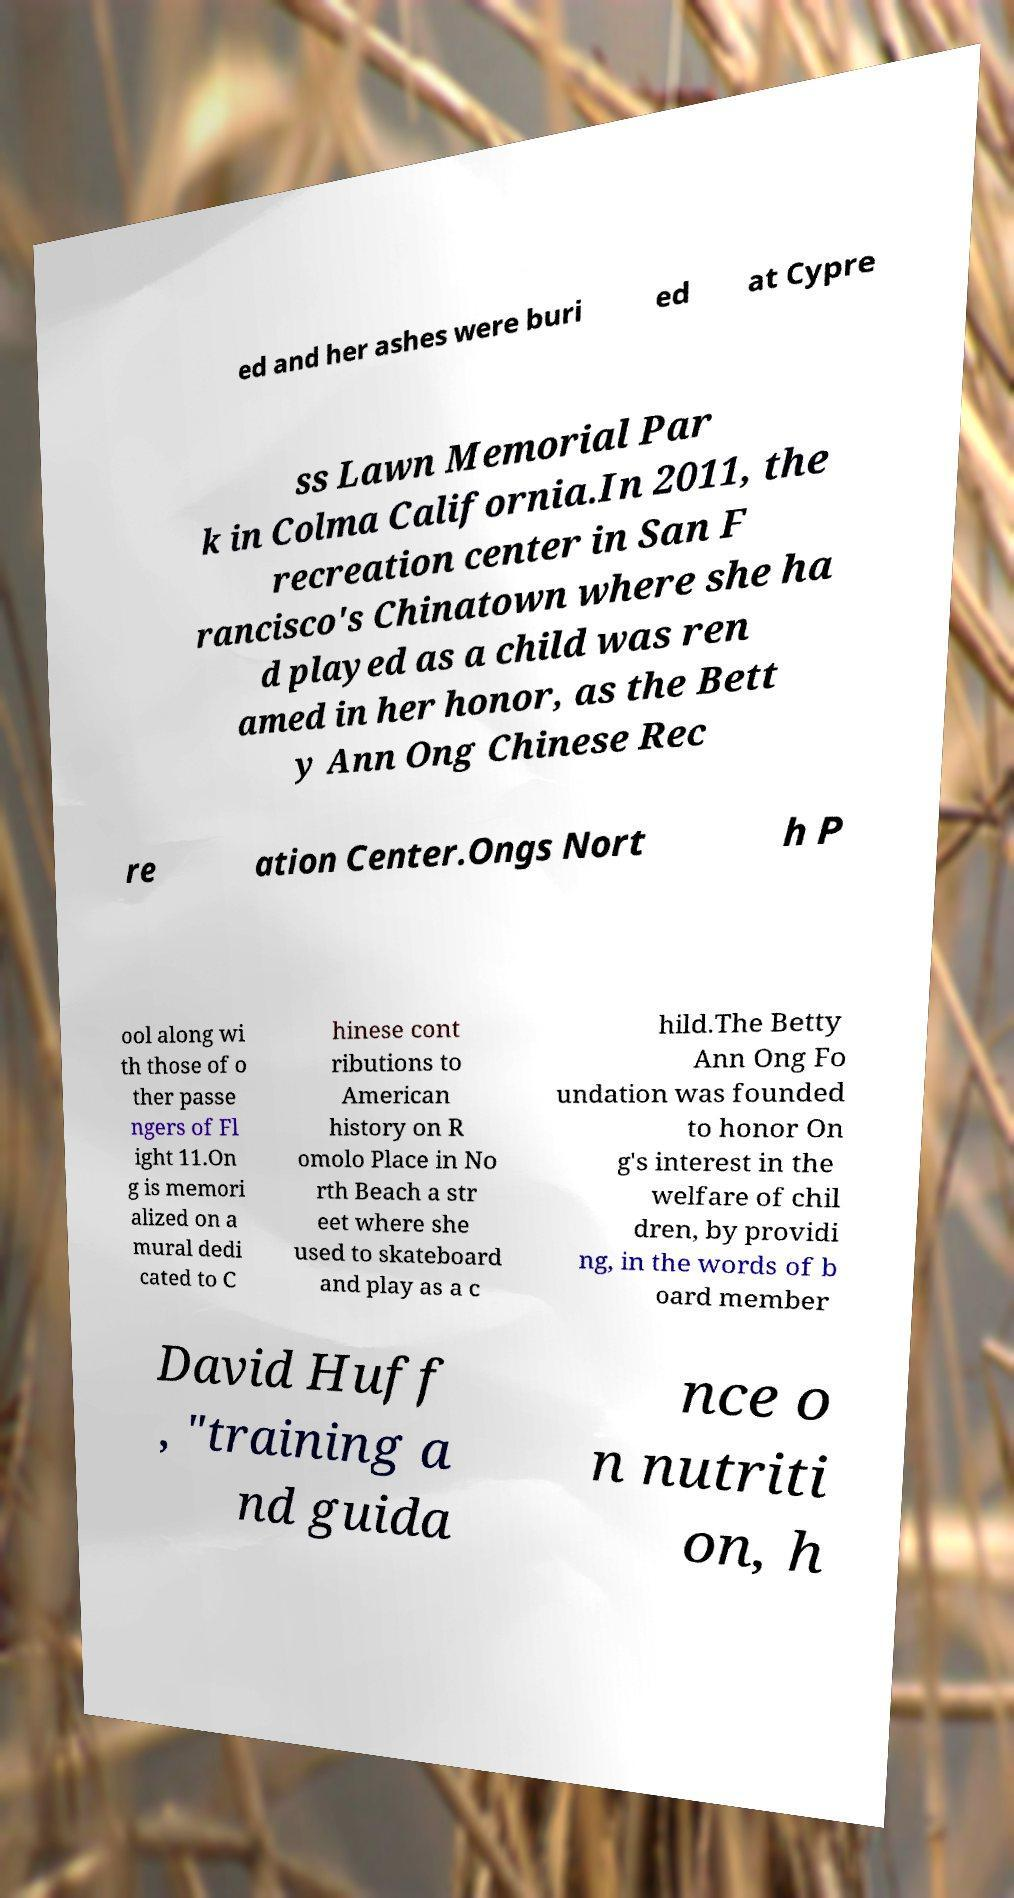Please read and relay the text visible in this image. What does it say? ed and her ashes were buri ed at Cypre ss Lawn Memorial Par k in Colma California.In 2011, the recreation center in San F rancisco's Chinatown where she ha d played as a child was ren amed in her honor, as the Bett y Ann Ong Chinese Rec re ation Center.Ongs Nort h P ool along wi th those of o ther passe ngers of Fl ight 11.On g is memori alized on a mural dedi cated to C hinese cont ributions to American history on R omolo Place in No rth Beach a str eet where she used to skateboard and play as a c hild.The Betty Ann Ong Fo undation was founded to honor On g's interest in the welfare of chil dren, by providi ng, in the words of b oard member David Huff , "training a nd guida nce o n nutriti on, h 